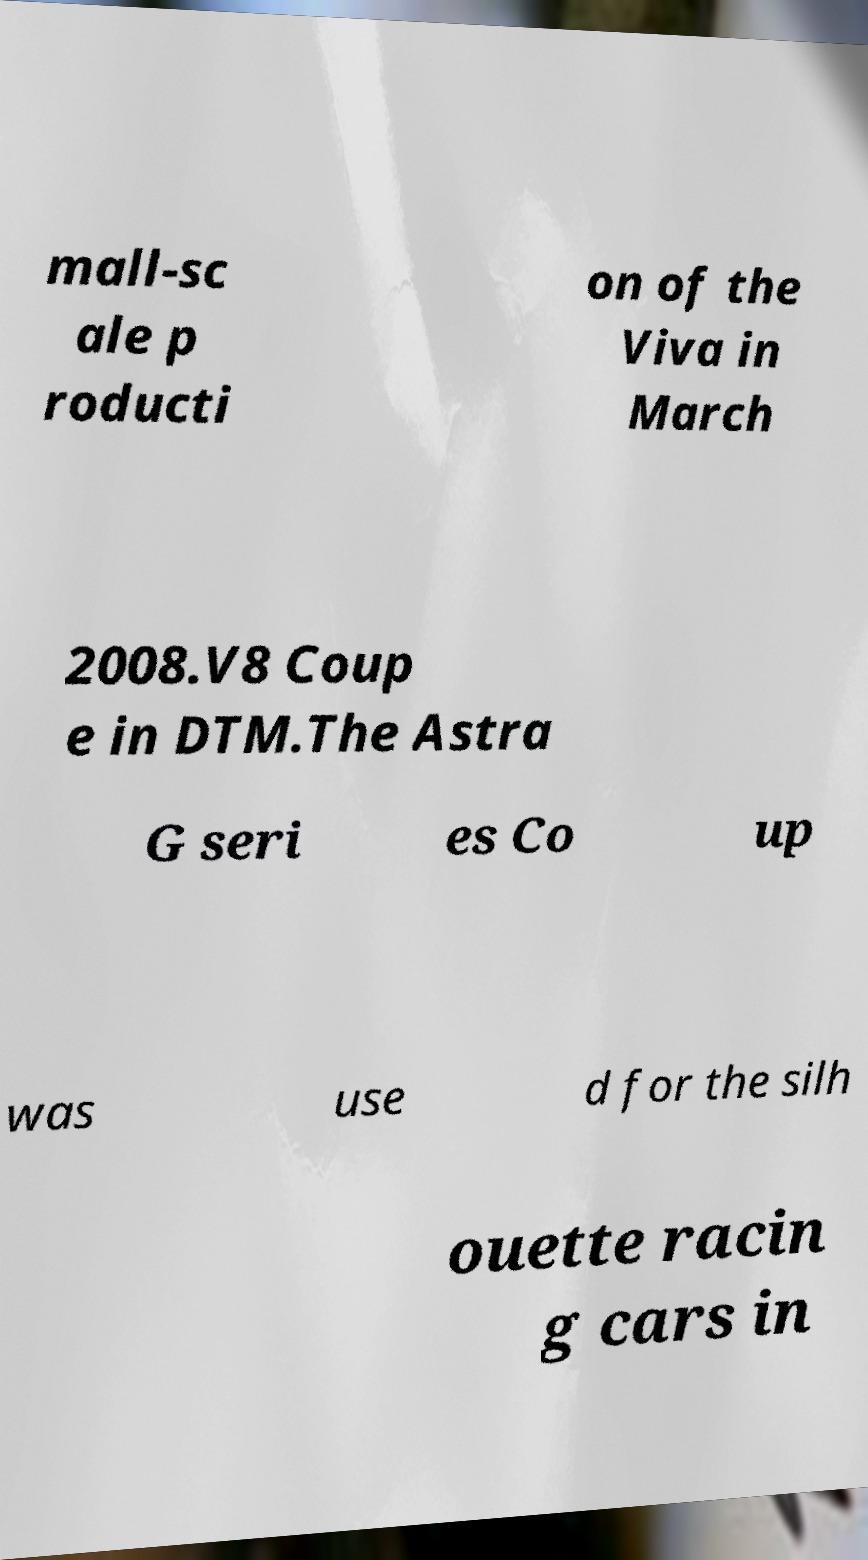What messages or text are displayed in this image? I need them in a readable, typed format. mall-sc ale p roducti on of the Viva in March 2008.V8 Coup e in DTM.The Astra G seri es Co up was use d for the silh ouette racin g cars in 